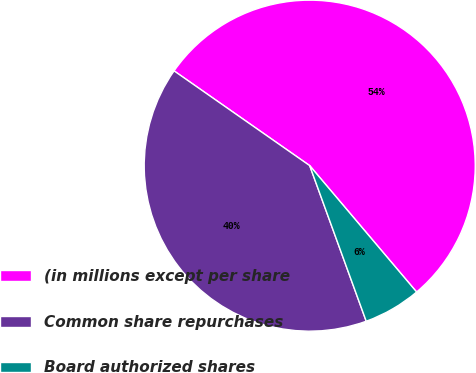Convert chart to OTSL. <chart><loc_0><loc_0><loc_500><loc_500><pie_chart><fcel>(in millions except per share<fcel>Common share repurchases<fcel>Board authorized shares<nl><fcel>54.12%<fcel>40.25%<fcel>5.63%<nl></chart> 